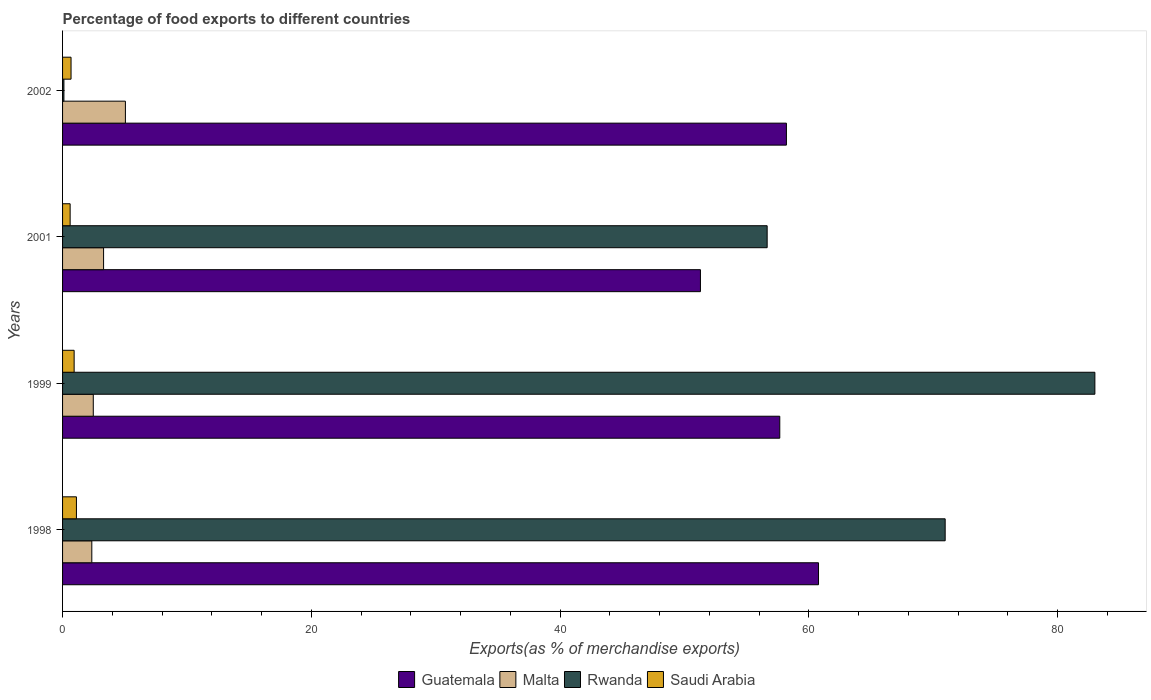How many different coloured bars are there?
Keep it short and to the point. 4. How many groups of bars are there?
Ensure brevity in your answer.  4. Are the number of bars on each tick of the Y-axis equal?
Your response must be concise. Yes. How many bars are there on the 3rd tick from the top?
Your response must be concise. 4. What is the label of the 4th group of bars from the top?
Give a very brief answer. 1998. In how many cases, is the number of bars for a given year not equal to the number of legend labels?
Offer a very short reply. 0. What is the percentage of exports to different countries in Guatemala in 2002?
Your response must be concise. 58.2. Across all years, what is the maximum percentage of exports to different countries in Malta?
Provide a short and direct response. 5.05. Across all years, what is the minimum percentage of exports to different countries in Guatemala?
Give a very brief answer. 51.29. What is the total percentage of exports to different countries in Saudi Arabia in the graph?
Your answer should be compact. 3.34. What is the difference between the percentage of exports to different countries in Rwanda in 1998 and that in 1999?
Offer a very short reply. -12.04. What is the difference between the percentage of exports to different countries in Malta in 1999 and the percentage of exports to different countries in Saudi Arabia in 2001?
Provide a short and direct response. 1.86. What is the average percentage of exports to different countries in Malta per year?
Keep it short and to the point. 3.29. In the year 1998, what is the difference between the percentage of exports to different countries in Rwanda and percentage of exports to different countries in Guatemala?
Ensure brevity in your answer.  10.18. What is the ratio of the percentage of exports to different countries in Malta in 1998 to that in 2001?
Your answer should be very brief. 0.71. What is the difference between the highest and the second highest percentage of exports to different countries in Rwanda?
Offer a terse response. 12.04. What is the difference between the highest and the lowest percentage of exports to different countries in Rwanda?
Keep it short and to the point. 82.9. Is it the case that in every year, the sum of the percentage of exports to different countries in Malta and percentage of exports to different countries in Saudi Arabia is greater than the sum of percentage of exports to different countries in Rwanda and percentage of exports to different countries in Guatemala?
Give a very brief answer. No. What does the 4th bar from the top in 1998 represents?
Ensure brevity in your answer.  Guatemala. What does the 3rd bar from the bottom in 2001 represents?
Offer a terse response. Rwanda. How many bars are there?
Make the answer very short. 16. Are all the bars in the graph horizontal?
Make the answer very short. Yes. What is the difference between two consecutive major ticks on the X-axis?
Keep it short and to the point. 20. Are the values on the major ticks of X-axis written in scientific E-notation?
Your response must be concise. No. Does the graph contain any zero values?
Give a very brief answer. No. What is the title of the graph?
Provide a short and direct response. Percentage of food exports to different countries. What is the label or title of the X-axis?
Make the answer very short. Exports(as % of merchandise exports). What is the label or title of the Y-axis?
Offer a very short reply. Years. What is the Exports(as % of merchandise exports) of Guatemala in 1998?
Provide a succinct answer. 60.78. What is the Exports(as % of merchandise exports) in Malta in 1998?
Your answer should be compact. 2.35. What is the Exports(as % of merchandise exports) in Rwanda in 1998?
Offer a very short reply. 70.97. What is the Exports(as % of merchandise exports) in Saudi Arabia in 1998?
Offer a very short reply. 1.11. What is the Exports(as % of merchandise exports) in Guatemala in 1999?
Make the answer very short. 57.67. What is the Exports(as % of merchandise exports) of Malta in 1999?
Ensure brevity in your answer.  2.47. What is the Exports(as % of merchandise exports) in Rwanda in 1999?
Keep it short and to the point. 83.01. What is the Exports(as % of merchandise exports) of Saudi Arabia in 1999?
Your answer should be compact. 0.93. What is the Exports(as % of merchandise exports) in Guatemala in 2001?
Offer a terse response. 51.29. What is the Exports(as % of merchandise exports) in Malta in 2001?
Keep it short and to the point. 3.3. What is the Exports(as % of merchandise exports) in Rwanda in 2001?
Ensure brevity in your answer.  56.66. What is the Exports(as % of merchandise exports) of Saudi Arabia in 2001?
Your answer should be very brief. 0.61. What is the Exports(as % of merchandise exports) of Guatemala in 2002?
Your answer should be compact. 58.2. What is the Exports(as % of merchandise exports) in Malta in 2002?
Provide a succinct answer. 5.05. What is the Exports(as % of merchandise exports) of Rwanda in 2002?
Ensure brevity in your answer.  0.11. What is the Exports(as % of merchandise exports) of Saudi Arabia in 2002?
Your response must be concise. 0.68. Across all years, what is the maximum Exports(as % of merchandise exports) in Guatemala?
Provide a succinct answer. 60.78. Across all years, what is the maximum Exports(as % of merchandise exports) of Malta?
Your answer should be very brief. 5.05. Across all years, what is the maximum Exports(as % of merchandise exports) of Rwanda?
Give a very brief answer. 83.01. Across all years, what is the maximum Exports(as % of merchandise exports) in Saudi Arabia?
Make the answer very short. 1.11. Across all years, what is the minimum Exports(as % of merchandise exports) of Guatemala?
Offer a terse response. 51.29. Across all years, what is the minimum Exports(as % of merchandise exports) of Malta?
Offer a very short reply. 2.35. Across all years, what is the minimum Exports(as % of merchandise exports) of Rwanda?
Your answer should be very brief. 0.11. Across all years, what is the minimum Exports(as % of merchandise exports) in Saudi Arabia?
Keep it short and to the point. 0.61. What is the total Exports(as % of merchandise exports) of Guatemala in the graph?
Offer a very short reply. 227.95. What is the total Exports(as % of merchandise exports) of Malta in the graph?
Your response must be concise. 13.17. What is the total Exports(as % of merchandise exports) of Rwanda in the graph?
Provide a succinct answer. 210.74. What is the total Exports(as % of merchandise exports) of Saudi Arabia in the graph?
Your response must be concise. 3.34. What is the difference between the Exports(as % of merchandise exports) of Guatemala in 1998 and that in 1999?
Keep it short and to the point. 3.11. What is the difference between the Exports(as % of merchandise exports) of Malta in 1998 and that in 1999?
Your response must be concise. -0.12. What is the difference between the Exports(as % of merchandise exports) in Rwanda in 1998 and that in 1999?
Keep it short and to the point. -12.04. What is the difference between the Exports(as % of merchandise exports) of Saudi Arabia in 1998 and that in 1999?
Your answer should be very brief. 0.18. What is the difference between the Exports(as % of merchandise exports) of Guatemala in 1998 and that in 2001?
Ensure brevity in your answer.  9.49. What is the difference between the Exports(as % of merchandise exports) in Malta in 1998 and that in 2001?
Your response must be concise. -0.95. What is the difference between the Exports(as % of merchandise exports) of Rwanda in 1998 and that in 2001?
Make the answer very short. 14.31. What is the difference between the Exports(as % of merchandise exports) in Saudi Arabia in 1998 and that in 2001?
Provide a succinct answer. 0.51. What is the difference between the Exports(as % of merchandise exports) of Guatemala in 1998 and that in 2002?
Make the answer very short. 2.58. What is the difference between the Exports(as % of merchandise exports) of Malta in 1998 and that in 2002?
Offer a terse response. -2.7. What is the difference between the Exports(as % of merchandise exports) of Rwanda in 1998 and that in 2002?
Your answer should be compact. 70.86. What is the difference between the Exports(as % of merchandise exports) in Saudi Arabia in 1998 and that in 2002?
Keep it short and to the point. 0.43. What is the difference between the Exports(as % of merchandise exports) in Guatemala in 1999 and that in 2001?
Provide a succinct answer. 6.38. What is the difference between the Exports(as % of merchandise exports) of Malta in 1999 and that in 2001?
Your answer should be very brief. -0.83. What is the difference between the Exports(as % of merchandise exports) in Rwanda in 1999 and that in 2001?
Provide a succinct answer. 26.35. What is the difference between the Exports(as % of merchandise exports) in Saudi Arabia in 1999 and that in 2001?
Provide a short and direct response. 0.32. What is the difference between the Exports(as % of merchandise exports) in Guatemala in 1999 and that in 2002?
Your answer should be compact. -0.53. What is the difference between the Exports(as % of merchandise exports) of Malta in 1999 and that in 2002?
Your response must be concise. -2.58. What is the difference between the Exports(as % of merchandise exports) in Rwanda in 1999 and that in 2002?
Provide a short and direct response. 82.9. What is the difference between the Exports(as % of merchandise exports) of Saudi Arabia in 1999 and that in 2002?
Your answer should be compact. 0.25. What is the difference between the Exports(as % of merchandise exports) in Guatemala in 2001 and that in 2002?
Keep it short and to the point. -6.91. What is the difference between the Exports(as % of merchandise exports) in Malta in 2001 and that in 2002?
Your response must be concise. -1.75. What is the difference between the Exports(as % of merchandise exports) of Rwanda in 2001 and that in 2002?
Give a very brief answer. 56.55. What is the difference between the Exports(as % of merchandise exports) in Saudi Arabia in 2001 and that in 2002?
Your answer should be very brief. -0.07. What is the difference between the Exports(as % of merchandise exports) in Guatemala in 1998 and the Exports(as % of merchandise exports) in Malta in 1999?
Offer a terse response. 58.31. What is the difference between the Exports(as % of merchandise exports) of Guatemala in 1998 and the Exports(as % of merchandise exports) of Rwanda in 1999?
Provide a succinct answer. -22.22. What is the difference between the Exports(as % of merchandise exports) of Guatemala in 1998 and the Exports(as % of merchandise exports) of Saudi Arabia in 1999?
Ensure brevity in your answer.  59.85. What is the difference between the Exports(as % of merchandise exports) in Malta in 1998 and the Exports(as % of merchandise exports) in Rwanda in 1999?
Provide a short and direct response. -80.66. What is the difference between the Exports(as % of merchandise exports) in Malta in 1998 and the Exports(as % of merchandise exports) in Saudi Arabia in 1999?
Keep it short and to the point. 1.42. What is the difference between the Exports(as % of merchandise exports) of Rwanda in 1998 and the Exports(as % of merchandise exports) of Saudi Arabia in 1999?
Provide a short and direct response. 70.04. What is the difference between the Exports(as % of merchandise exports) in Guatemala in 1998 and the Exports(as % of merchandise exports) in Malta in 2001?
Give a very brief answer. 57.49. What is the difference between the Exports(as % of merchandise exports) in Guatemala in 1998 and the Exports(as % of merchandise exports) in Rwanda in 2001?
Offer a very short reply. 4.13. What is the difference between the Exports(as % of merchandise exports) of Guatemala in 1998 and the Exports(as % of merchandise exports) of Saudi Arabia in 2001?
Ensure brevity in your answer.  60.17. What is the difference between the Exports(as % of merchandise exports) in Malta in 1998 and the Exports(as % of merchandise exports) in Rwanda in 2001?
Provide a succinct answer. -54.3. What is the difference between the Exports(as % of merchandise exports) in Malta in 1998 and the Exports(as % of merchandise exports) in Saudi Arabia in 2001?
Your response must be concise. 1.74. What is the difference between the Exports(as % of merchandise exports) of Rwanda in 1998 and the Exports(as % of merchandise exports) of Saudi Arabia in 2001?
Ensure brevity in your answer.  70.36. What is the difference between the Exports(as % of merchandise exports) of Guatemala in 1998 and the Exports(as % of merchandise exports) of Malta in 2002?
Offer a terse response. 55.73. What is the difference between the Exports(as % of merchandise exports) in Guatemala in 1998 and the Exports(as % of merchandise exports) in Rwanda in 2002?
Your response must be concise. 60.68. What is the difference between the Exports(as % of merchandise exports) in Guatemala in 1998 and the Exports(as % of merchandise exports) in Saudi Arabia in 2002?
Provide a short and direct response. 60.1. What is the difference between the Exports(as % of merchandise exports) of Malta in 1998 and the Exports(as % of merchandise exports) of Rwanda in 2002?
Ensure brevity in your answer.  2.24. What is the difference between the Exports(as % of merchandise exports) in Malta in 1998 and the Exports(as % of merchandise exports) in Saudi Arabia in 2002?
Your answer should be very brief. 1.67. What is the difference between the Exports(as % of merchandise exports) in Rwanda in 1998 and the Exports(as % of merchandise exports) in Saudi Arabia in 2002?
Provide a short and direct response. 70.29. What is the difference between the Exports(as % of merchandise exports) in Guatemala in 1999 and the Exports(as % of merchandise exports) in Malta in 2001?
Offer a very short reply. 54.37. What is the difference between the Exports(as % of merchandise exports) in Guatemala in 1999 and the Exports(as % of merchandise exports) in Rwanda in 2001?
Offer a very short reply. 1.01. What is the difference between the Exports(as % of merchandise exports) in Guatemala in 1999 and the Exports(as % of merchandise exports) in Saudi Arabia in 2001?
Make the answer very short. 57.06. What is the difference between the Exports(as % of merchandise exports) in Malta in 1999 and the Exports(as % of merchandise exports) in Rwanda in 2001?
Ensure brevity in your answer.  -54.19. What is the difference between the Exports(as % of merchandise exports) in Malta in 1999 and the Exports(as % of merchandise exports) in Saudi Arabia in 2001?
Provide a succinct answer. 1.86. What is the difference between the Exports(as % of merchandise exports) of Rwanda in 1999 and the Exports(as % of merchandise exports) of Saudi Arabia in 2001?
Offer a terse response. 82.4. What is the difference between the Exports(as % of merchandise exports) of Guatemala in 1999 and the Exports(as % of merchandise exports) of Malta in 2002?
Provide a succinct answer. 52.62. What is the difference between the Exports(as % of merchandise exports) in Guatemala in 1999 and the Exports(as % of merchandise exports) in Rwanda in 2002?
Your response must be concise. 57.56. What is the difference between the Exports(as % of merchandise exports) of Guatemala in 1999 and the Exports(as % of merchandise exports) of Saudi Arabia in 2002?
Give a very brief answer. 56.99. What is the difference between the Exports(as % of merchandise exports) of Malta in 1999 and the Exports(as % of merchandise exports) of Rwanda in 2002?
Keep it short and to the point. 2.36. What is the difference between the Exports(as % of merchandise exports) of Malta in 1999 and the Exports(as % of merchandise exports) of Saudi Arabia in 2002?
Offer a very short reply. 1.79. What is the difference between the Exports(as % of merchandise exports) in Rwanda in 1999 and the Exports(as % of merchandise exports) in Saudi Arabia in 2002?
Provide a succinct answer. 82.33. What is the difference between the Exports(as % of merchandise exports) in Guatemala in 2001 and the Exports(as % of merchandise exports) in Malta in 2002?
Your answer should be very brief. 46.24. What is the difference between the Exports(as % of merchandise exports) in Guatemala in 2001 and the Exports(as % of merchandise exports) in Rwanda in 2002?
Provide a short and direct response. 51.18. What is the difference between the Exports(as % of merchandise exports) of Guatemala in 2001 and the Exports(as % of merchandise exports) of Saudi Arabia in 2002?
Your response must be concise. 50.61. What is the difference between the Exports(as % of merchandise exports) in Malta in 2001 and the Exports(as % of merchandise exports) in Rwanda in 2002?
Give a very brief answer. 3.19. What is the difference between the Exports(as % of merchandise exports) in Malta in 2001 and the Exports(as % of merchandise exports) in Saudi Arabia in 2002?
Your answer should be compact. 2.62. What is the difference between the Exports(as % of merchandise exports) in Rwanda in 2001 and the Exports(as % of merchandise exports) in Saudi Arabia in 2002?
Offer a terse response. 55.97. What is the average Exports(as % of merchandise exports) in Guatemala per year?
Provide a succinct answer. 56.99. What is the average Exports(as % of merchandise exports) of Malta per year?
Offer a very short reply. 3.29. What is the average Exports(as % of merchandise exports) of Rwanda per year?
Your answer should be very brief. 52.68. What is the average Exports(as % of merchandise exports) of Saudi Arabia per year?
Keep it short and to the point. 0.83. In the year 1998, what is the difference between the Exports(as % of merchandise exports) of Guatemala and Exports(as % of merchandise exports) of Malta?
Give a very brief answer. 58.43. In the year 1998, what is the difference between the Exports(as % of merchandise exports) in Guatemala and Exports(as % of merchandise exports) in Rwanda?
Your answer should be very brief. -10.18. In the year 1998, what is the difference between the Exports(as % of merchandise exports) in Guatemala and Exports(as % of merchandise exports) in Saudi Arabia?
Offer a very short reply. 59.67. In the year 1998, what is the difference between the Exports(as % of merchandise exports) in Malta and Exports(as % of merchandise exports) in Rwanda?
Provide a short and direct response. -68.62. In the year 1998, what is the difference between the Exports(as % of merchandise exports) in Malta and Exports(as % of merchandise exports) in Saudi Arabia?
Your response must be concise. 1.24. In the year 1998, what is the difference between the Exports(as % of merchandise exports) of Rwanda and Exports(as % of merchandise exports) of Saudi Arabia?
Provide a succinct answer. 69.85. In the year 1999, what is the difference between the Exports(as % of merchandise exports) in Guatemala and Exports(as % of merchandise exports) in Malta?
Offer a very short reply. 55.2. In the year 1999, what is the difference between the Exports(as % of merchandise exports) in Guatemala and Exports(as % of merchandise exports) in Rwanda?
Make the answer very short. -25.34. In the year 1999, what is the difference between the Exports(as % of merchandise exports) in Guatemala and Exports(as % of merchandise exports) in Saudi Arabia?
Your answer should be very brief. 56.74. In the year 1999, what is the difference between the Exports(as % of merchandise exports) of Malta and Exports(as % of merchandise exports) of Rwanda?
Ensure brevity in your answer.  -80.54. In the year 1999, what is the difference between the Exports(as % of merchandise exports) of Malta and Exports(as % of merchandise exports) of Saudi Arabia?
Your answer should be very brief. 1.54. In the year 1999, what is the difference between the Exports(as % of merchandise exports) in Rwanda and Exports(as % of merchandise exports) in Saudi Arabia?
Make the answer very short. 82.08. In the year 2001, what is the difference between the Exports(as % of merchandise exports) of Guatemala and Exports(as % of merchandise exports) of Malta?
Make the answer very short. 47.99. In the year 2001, what is the difference between the Exports(as % of merchandise exports) of Guatemala and Exports(as % of merchandise exports) of Rwanda?
Provide a succinct answer. -5.37. In the year 2001, what is the difference between the Exports(as % of merchandise exports) in Guatemala and Exports(as % of merchandise exports) in Saudi Arabia?
Provide a succinct answer. 50.68. In the year 2001, what is the difference between the Exports(as % of merchandise exports) in Malta and Exports(as % of merchandise exports) in Rwanda?
Your response must be concise. -53.36. In the year 2001, what is the difference between the Exports(as % of merchandise exports) in Malta and Exports(as % of merchandise exports) in Saudi Arabia?
Offer a very short reply. 2.69. In the year 2001, what is the difference between the Exports(as % of merchandise exports) of Rwanda and Exports(as % of merchandise exports) of Saudi Arabia?
Provide a short and direct response. 56.05. In the year 2002, what is the difference between the Exports(as % of merchandise exports) of Guatemala and Exports(as % of merchandise exports) of Malta?
Offer a terse response. 53.15. In the year 2002, what is the difference between the Exports(as % of merchandise exports) of Guatemala and Exports(as % of merchandise exports) of Rwanda?
Offer a very short reply. 58.1. In the year 2002, what is the difference between the Exports(as % of merchandise exports) of Guatemala and Exports(as % of merchandise exports) of Saudi Arabia?
Offer a very short reply. 57.52. In the year 2002, what is the difference between the Exports(as % of merchandise exports) of Malta and Exports(as % of merchandise exports) of Rwanda?
Give a very brief answer. 4.94. In the year 2002, what is the difference between the Exports(as % of merchandise exports) of Malta and Exports(as % of merchandise exports) of Saudi Arabia?
Make the answer very short. 4.37. In the year 2002, what is the difference between the Exports(as % of merchandise exports) in Rwanda and Exports(as % of merchandise exports) in Saudi Arabia?
Ensure brevity in your answer.  -0.57. What is the ratio of the Exports(as % of merchandise exports) in Guatemala in 1998 to that in 1999?
Your answer should be compact. 1.05. What is the ratio of the Exports(as % of merchandise exports) in Malta in 1998 to that in 1999?
Provide a succinct answer. 0.95. What is the ratio of the Exports(as % of merchandise exports) of Rwanda in 1998 to that in 1999?
Your response must be concise. 0.85. What is the ratio of the Exports(as % of merchandise exports) in Saudi Arabia in 1998 to that in 1999?
Offer a very short reply. 1.2. What is the ratio of the Exports(as % of merchandise exports) of Guatemala in 1998 to that in 2001?
Offer a very short reply. 1.19. What is the ratio of the Exports(as % of merchandise exports) in Malta in 1998 to that in 2001?
Make the answer very short. 0.71. What is the ratio of the Exports(as % of merchandise exports) of Rwanda in 1998 to that in 2001?
Keep it short and to the point. 1.25. What is the ratio of the Exports(as % of merchandise exports) in Saudi Arabia in 1998 to that in 2001?
Offer a terse response. 1.83. What is the ratio of the Exports(as % of merchandise exports) in Guatemala in 1998 to that in 2002?
Make the answer very short. 1.04. What is the ratio of the Exports(as % of merchandise exports) of Malta in 1998 to that in 2002?
Your answer should be very brief. 0.47. What is the ratio of the Exports(as % of merchandise exports) in Rwanda in 1998 to that in 2002?
Offer a very short reply. 654.31. What is the ratio of the Exports(as % of merchandise exports) of Saudi Arabia in 1998 to that in 2002?
Your answer should be very brief. 1.64. What is the ratio of the Exports(as % of merchandise exports) in Guatemala in 1999 to that in 2001?
Provide a short and direct response. 1.12. What is the ratio of the Exports(as % of merchandise exports) in Malta in 1999 to that in 2001?
Offer a very short reply. 0.75. What is the ratio of the Exports(as % of merchandise exports) of Rwanda in 1999 to that in 2001?
Your answer should be compact. 1.47. What is the ratio of the Exports(as % of merchandise exports) of Saudi Arabia in 1999 to that in 2001?
Ensure brevity in your answer.  1.53. What is the ratio of the Exports(as % of merchandise exports) in Malta in 1999 to that in 2002?
Give a very brief answer. 0.49. What is the ratio of the Exports(as % of merchandise exports) of Rwanda in 1999 to that in 2002?
Your answer should be compact. 765.3. What is the ratio of the Exports(as % of merchandise exports) of Saudi Arabia in 1999 to that in 2002?
Provide a short and direct response. 1.37. What is the ratio of the Exports(as % of merchandise exports) in Guatemala in 2001 to that in 2002?
Ensure brevity in your answer.  0.88. What is the ratio of the Exports(as % of merchandise exports) in Malta in 2001 to that in 2002?
Provide a succinct answer. 0.65. What is the ratio of the Exports(as % of merchandise exports) of Rwanda in 2001 to that in 2002?
Keep it short and to the point. 522.35. What is the ratio of the Exports(as % of merchandise exports) of Saudi Arabia in 2001 to that in 2002?
Offer a terse response. 0.89. What is the difference between the highest and the second highest Exports(as % of merchandise exports) in Guatemala?
Your answer should be very brief. 2.58. What is the difference between the highest and the second highest Exports(as % of merchandise exports) in Malta?
Give a very brief answer. 1.75. What is the difference between the highest and the second highest Exports(as % of merchandise exports) of Rwanda?
Your answer should be very brief. 12.04. What is the difference between the highest and the second highest Exports(as % of merchandise exports) in Saudi Arabia?
Provide a succinct answer. 0.18. What is the difference between the highest and the lowest Exports(as % of merchandise exports) of Guatemala?
Give a very brief answer. 9.49. What is the difference between the highest and the lowest Exports(as % of merchandise exports) in Malta?
Your answer should be compact. 2.7. What is the difference between the highest and the lowest Exports(as % of merchandise exports) of Rwanda?
Your answer should be very brief. 82.9. What is the difference between the highest and the lowest Exports(as % of merchandise exports) of Saudi Arabia?
Give a very brief answer. 0.51. 